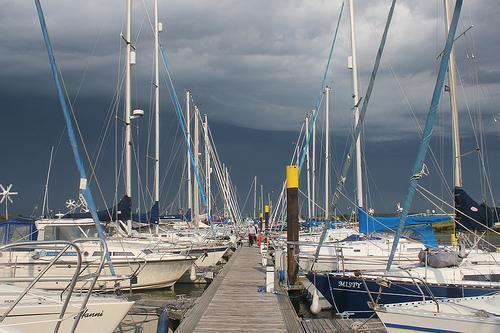How many of the boats are blue?
Give a very brief answer. 1. 